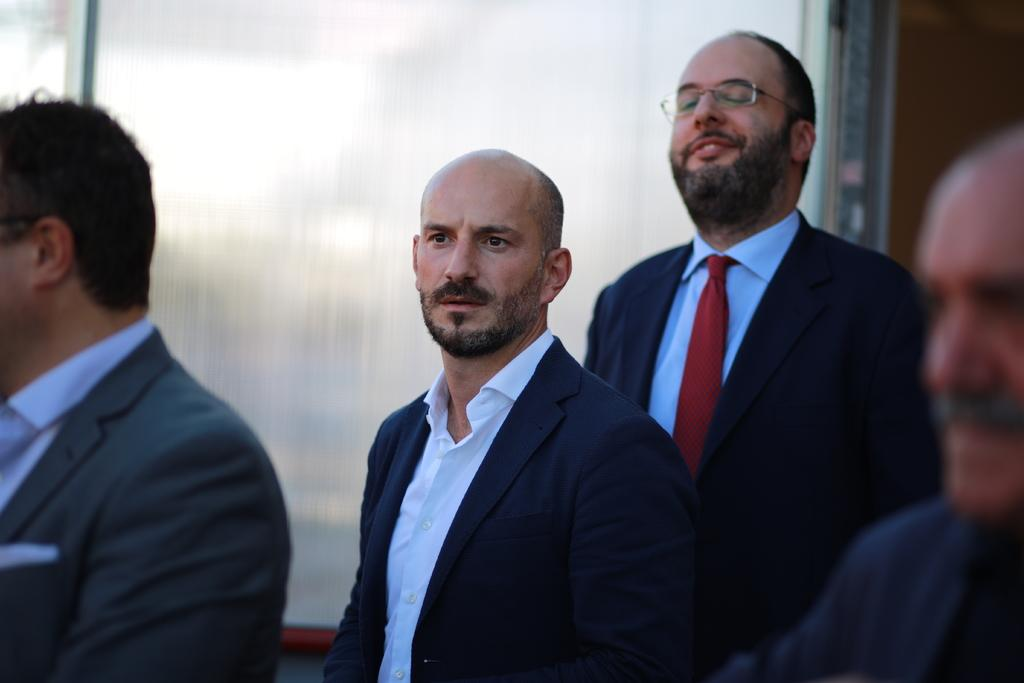How many people are in the image? There are three people in the image. What are the people wearing? All three people are wearing suits. Are there any additional accessories being worn by the people? Yes, one man is wearing a tie, and another man is wearing spectacles. What is the value of the bait used by the people in the image? There is no mention of bait or any fishing activity in the image, so it is not possible to determine its value. 